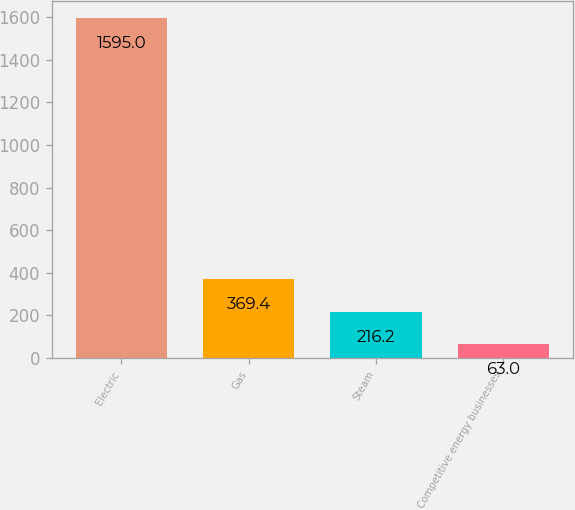<chart> <loc_0><loc_0><loc_500><loc_500><bar_chart><fcel>Electric<fcel>Gas<fcel>Steam<fcel>Competitive energy businesses<nl><fcel>1595<fcel>369.4<fcel>216.2<fcel>63<nl></chart> 